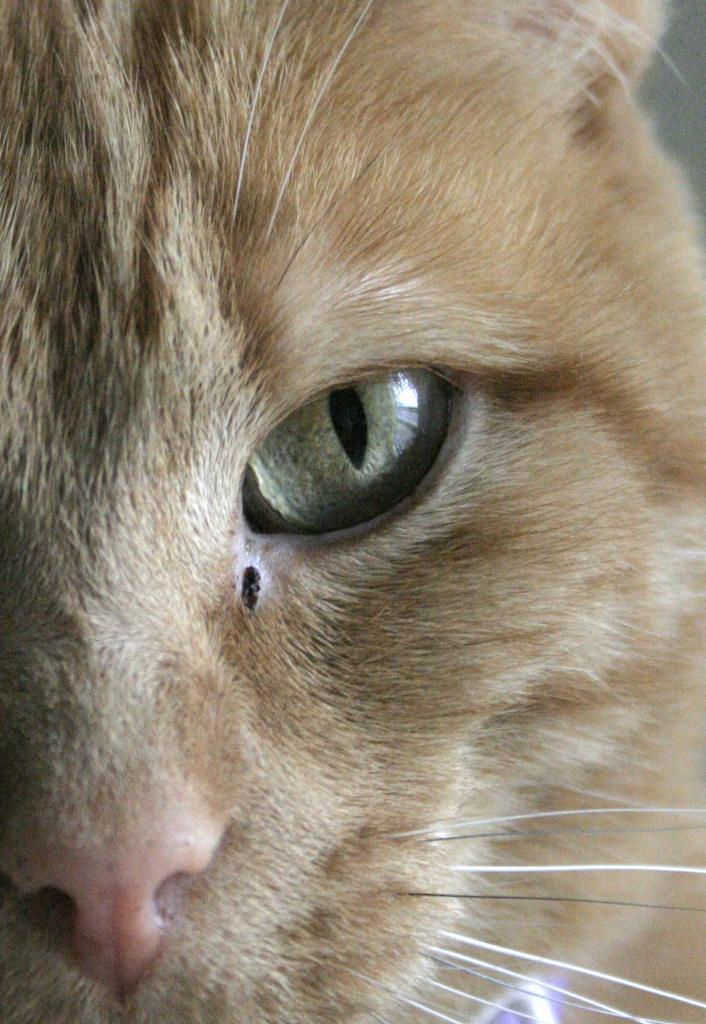What type of creature is in the image? There is an animal in the image, which looks like a cat. What type of zinc is being advertised in the image? There is no zinc or advertisement present in the image; it features an animal that looks like a cat. What type of system is being used to display the image? The question about the system being used to display the image is not relevant to the facts provided, as the focus is on the content of the image itself. 